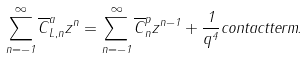<formula> <loc_0><loc_0><loc_500><loc_500>\sum _ { n = - 1 } ^ { \infty } \overline { C } ^ { a } _ { L , n } z ^ { n } = \sum _ { n = - 1 } ^ { \infty } \overline { C } ^ { p } _ { n } z ^ { n - 1 } + \frac { 1 } { q ^ { 4 } } c o n t a c t t e r m .</formula> 